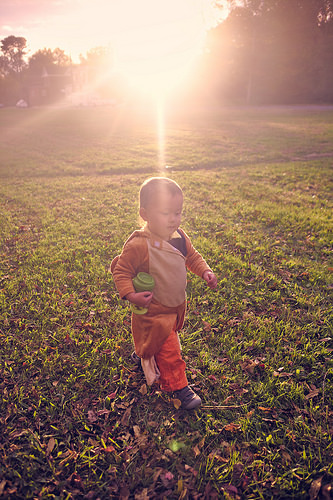<image>
Can you confirm if the sun is behind the child? Yes. From this viewpoint, the sun is positioned behind the child, with the child partially or fully occluding the sun. 